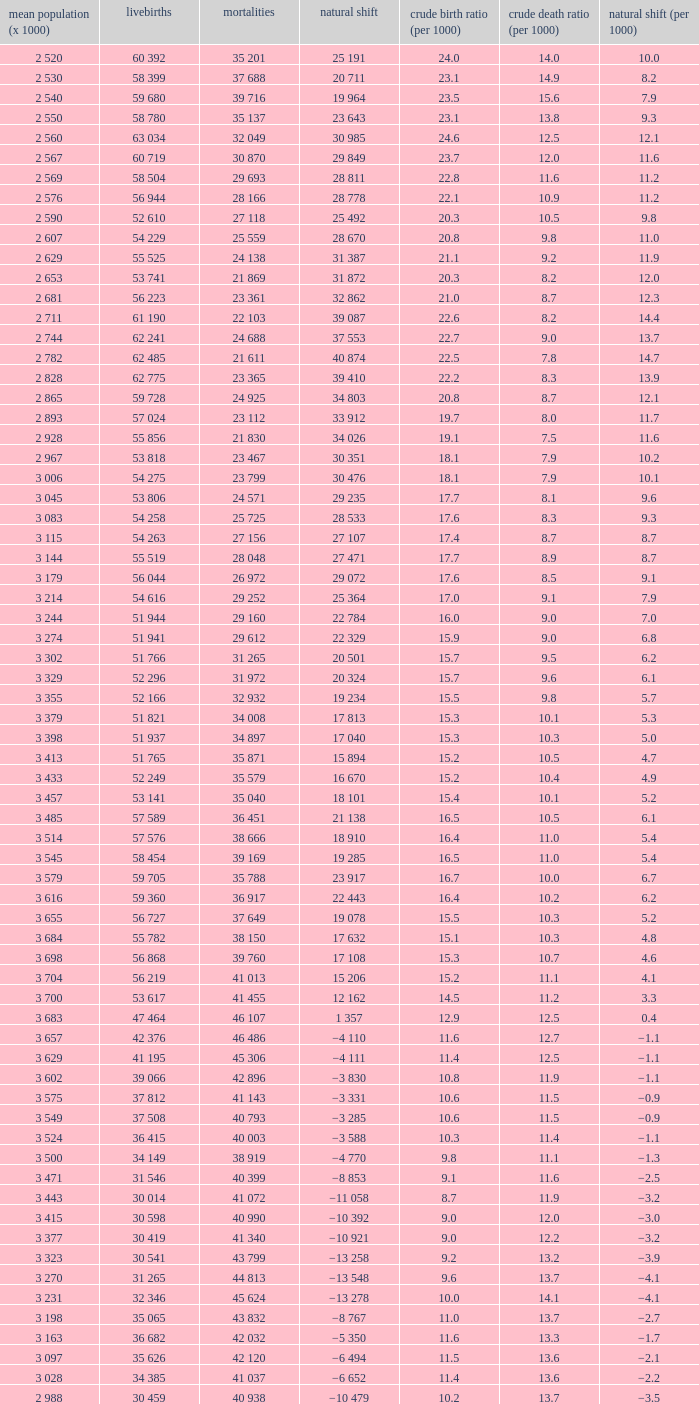Which Natural change has a Crude death rate (per 1000) larger than 9, and Deaths of 40 399? −8 853. 